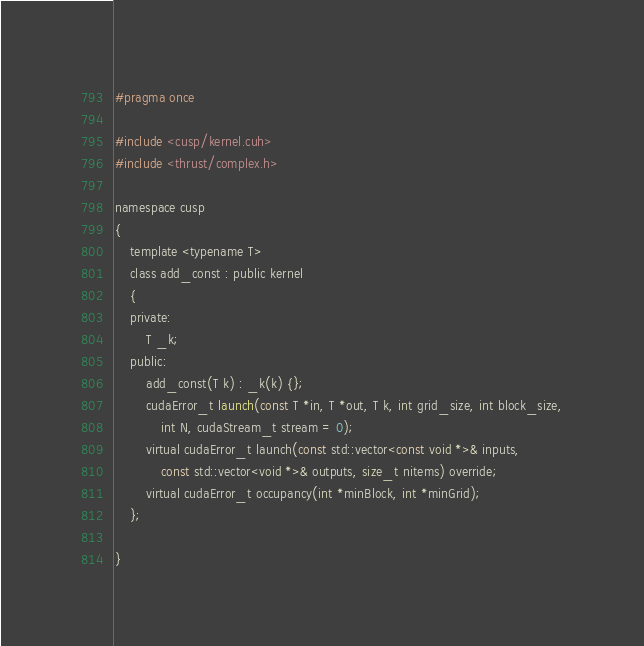<code> <loc_0><loc_0><loc_500><loc_500><_Cuda_>#pragma once

#include <cusp/kernel.cuh>
#include <thrust/complex.h>

namespace cusp
{
    template <typename T>
    class add_const : public kernel
    {
    private:
        T _k;
    public:
        add_const(T k) : _k(k) {};
        cudaError_t launch(const T *in, T *out, T k, int grid_size, int block_size,
            int N, cudaStream_t stream = 0);
        virtual cudaError_t launch(const std::vector<const void *>& inputs,
            const std::vector<void *>& outputs, size_t nitems) override;
        virtual cudaError_t occupancy(int *minBlock, int *minGrid);
    };

}</code> 